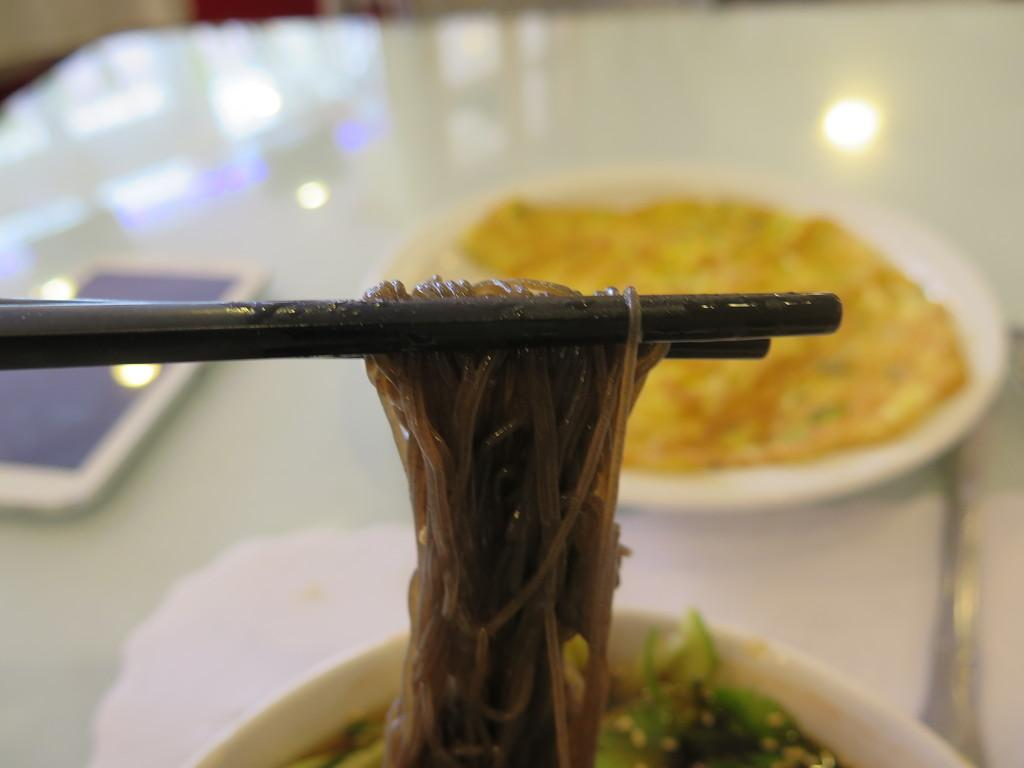What type of furniture is in the image? There is a table in the image. What is placed on the table? There is a plate, a mobile, chopsticks, and fast food on the table. What might be used for eating the fast food on the table? Chopsticks are visible on the table for eating the fast food. What type of pies can be seen on the table in the image? There are no pies present on the table in the image; it features fast food and chopsticks. 